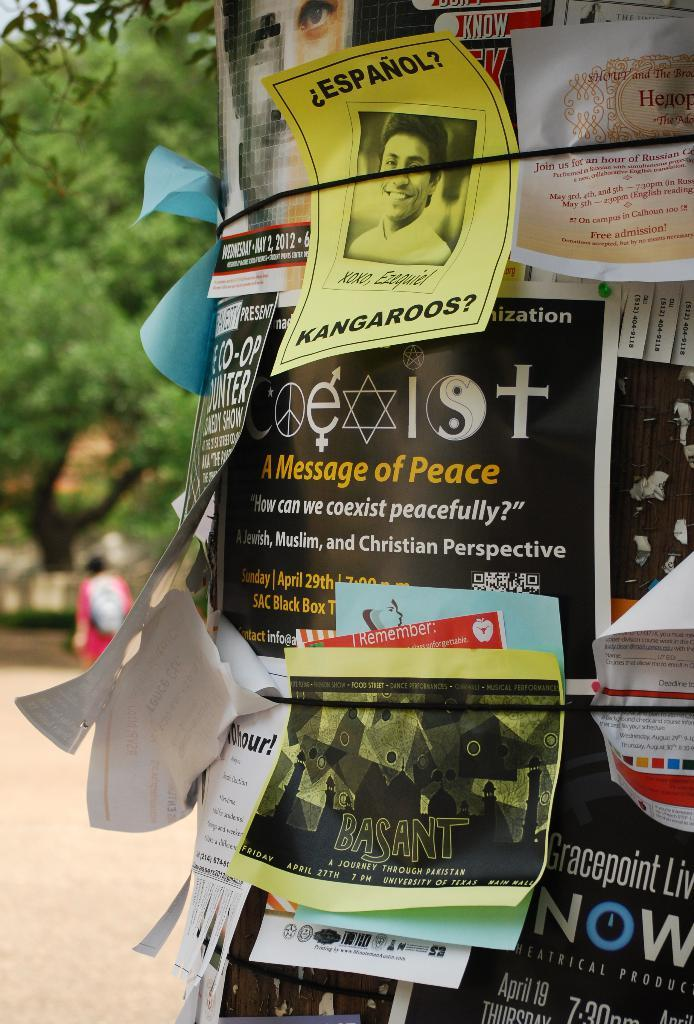Provide a one-sentence caption for the provided image. Numerous signs on a pole, one reads A message of Peace. 